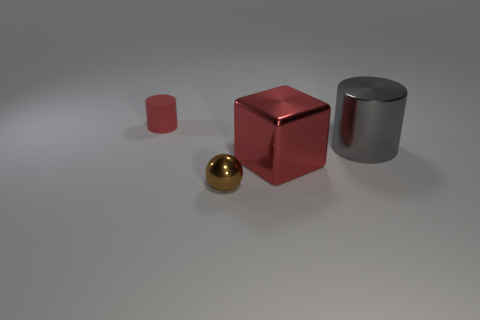What materials do the objects in the image appear to be made of? The objects in the image seem to be rendered with different finishes that suggest a variety of materials. The tiny ball and the cylinder have reflective surfaces, indicating they could be made of metals such as brass or steel. The cube and the smaller cuboid have a matte finish, which could suggest a painted metal or a non-metallic material like plastic. 